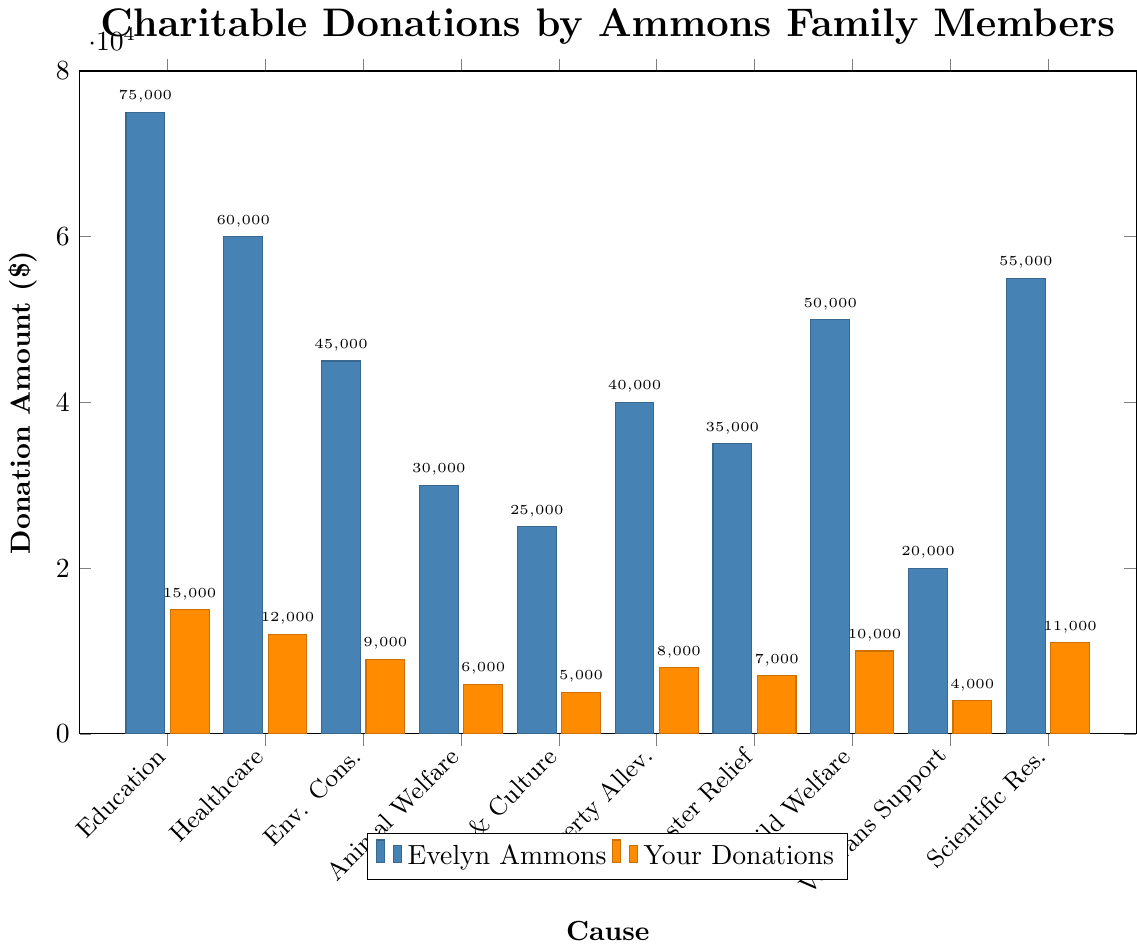What cause received the highest total donations from Evelyn Ammons? Look for the tallest bar in the "Evelyn Ammons" set of bars. The tallest bar is for the "Education" cause.
Answer: Education Which cause had the smallest difference in donations between you and Evelyn Ammons? Calculate the absolute difference for each cause. Differences: Education (60000), Healthcare (48000), Environmental Conservation (36000), Animal Welfare (24000), Arts and Culture (20000), Poverty Alleviation (32000), Disaster Relief (28000), Child Welfare (40000), Veterans Support (16000), Scientific Research (44000). The smallest difference is for "Veterans Support".
Answer: Veterans Support What is the total amount donated by Evelyn Ammons for Healthcare and Child Welfare combined? Sum the donations by Evelyn Ammons for Healthcare and Child Welfare (60000 + 50000).
Answer: 110000 How does the donation amount for Environmental Conservation compare between Evelyn Ammons and your donations? Compare the heights of the bars for Environmental Conservation. Evelyn Ammons donated 45000, and you donated 9000, which means Evelyn donated 5 times more than you.
Answer: 5 times more What is the average donation amount for all causes by Evelyn Ammons? Sum all donation amounts by Evelyn Ammons and divide by the number of causes. (75000 + 60000 + 45000 + 30000 + 25000 + 40000 + 35000 + 50000 + 20000 + 55000) = 435000. Divide by 10 causes.
Answer: 43500 Which cause shows Evelyn Ammons' donations being precisely 4 times yours? Look for the causes where Evelyn Ammons' donation is 4 times that of your donation. For Animal Welfare (6000 x 4 = 24000), Evelyn Ammons donated 30000, so no match. Repeat for each cause. Only "Arts and Culture" (5000 x 4 = 20000) might seem close, but Evelyn donated 25000. None exactly match 4 times.
Answer: None Which causes had donation differences of more than 50000 between Evelyn Ammons and your donations? Calculate the differences for each cause. Differences over 50000: Education (60000).
Answer: Education 